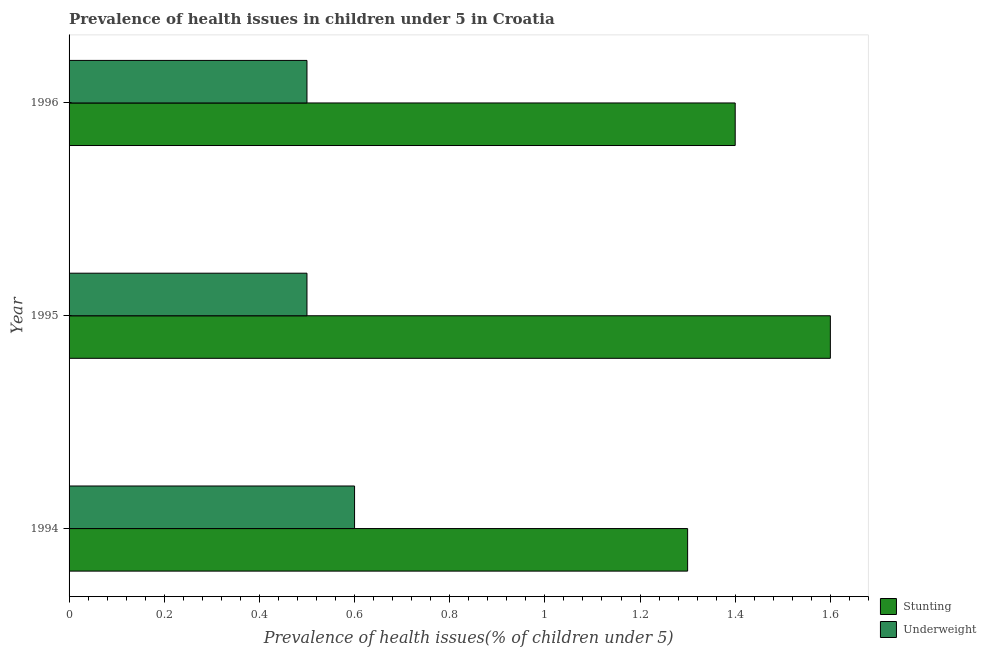Are the number of bars per tick equal to the number of legend labels?
Keep it short and to the point. Yes. Are the number of bars on each tick of the Y-axis equal?
Give a very brief answer. Yes. How many bars are there on the 2nd tick from the top?
Make the answer very short. 2. How many bars are there on the 2nd tick from the bottom?
Provide a short and direct response. 2. In how many cases, is the number of bars for a given year not equal to the number of legend labels?
Your response must be concise. 0. What is the percentage of stunted children in 1994?
Give a very brief answer. 1.3. Across all years, what is the maximum percentage of underweight children?
Your answer should be compact. 0.6. Across all years, what is the minimum percentage of underweight children?
Ensure brevity in your answer.  0.5. In which year was the percentage of underweight children maximum?
Your answer should be compact. 1994. In which year was the percentage of underweight children minimum?
Provide a succinct answer. 1995. What is the total percentage of stunted children in the graph?
Offer a very short reply. 4.3. What is the difference between the percentage of stunted children in 1995 and the percentage of underweight children in 1996?
Your answer should be very brief. 1.1. What is the average percentage of stunted children per year?
Your answer should be very brief. 1.43. Is the percentage of underweight children in 1994 less than that in 1995?
Your response must be concise. No. Is the difference between the percentage of underweight children in 1994 and 1995 greater than the difference between the percentage of stunted children in 1994 and 1995?
Make the answer very short. Yes. What is the difference between the highest and the second highest percentage of underweight children?
Provide a succinct answer. 0.1. In how many years, is the percentage of underweight children greater than the average percentage of underweight children taken over all years?
Provide a short and direct response. 1. Is the sum of the percentage of stunted children in 1994 and 1995 greater than the maximum percentage of underweight children across all years?
Your answer should be very brief. Yes. What does the 2nd bar from the top in 1994 represents?
Offer a terse response. Stunting. What does the 2nd bar from the bottom in 1995 represents?
Provide a succinct answer. Underweight. Are all the bars in the graph horizontal?
Provide a succinct answer. Yes. How many years are there in the graph?
Your response must be concise. 3. Are the values on the major ticks of X-axis written in scientific E-notation?
Offer a very short reply. No. Does the graph contain any zero values?
Offer a terse response. No. Where does the legend appear in the graph?
Make the answer very short. Bottom right. How are the legend labels stacked?
Your answer should be very brief. Vertical. What is the title of the graph?
Keep it short and to the point. Prevalence of health issues in children under 5 in Croatia. Does "Resident workers" appear as one of the legend labels in the graph?
Give a very brief answer. No. What is the label or title of the X-axis?
Give a very brief answer. Prevalence of health issues(% of children under 5). What is the label or title of the Y-axis?
Provide a succinct answer. Year. What is the Prevalence of health issues(% of children under 5) in Stunting in 1994?
Make the answer very short. 1.3. What is the Prevalence of health issues(% of children under 5) in Underweight in 1994?
Keep it short and to the point. 0.6. What is the Prevalence of health issues(% of children under 5) in Stunting in 1995?
Your response must be concise. 1.6. What is the Prevalence of health issues(% of children under 5) of Stunting in 1996?
Your answer should be compact. 1.4. Across all years, what is the maximum Prevalence of health issues(% of children under 5) of Stunting?
Make the answer very short. 1.6. Across all years, what is the maximum Prevalence of health issues(% of children under 5) in Underweight?
Offer a terse response. 0.6. Across all years, what is the minimum Prevalence of health issues(% of children under 5) in Stunting?
Your answer should be compact. 1.3. Across all years, what is the minimum Prevalence of health issues(% of children under 5) in Underweight?
Keep it short and to the point. 0.5. What is the total Prevalence of health issues(% of children under 5) of Underweight in the graph?
Your answer should be compact. 1.6. What is the difference between the Prevalence of health issues(% of children under 5) in Stunting in 1994 and that in 1995?
Keep it short and to the point. -0.3. What is the difference between the Prevalence of health issues(% of children under 5) of Underweight in 1994 and that in 1995?
Ensure brevity in your answer.  0.1. What is the difference between the Prevalence of health issues(% of children under 5) of Stunting in 1994 and that in 1996?
Provide a short and direct response. -0.1. What is the difference between the Prevalence of health issues(% of children under 5) in Underweight in 1994 and that in 1996?
Your response must be concise. 0.1. What is the difference between the Prevalence of health issues(% of children under 5) of Underweight in 1995 and that in 1996?
Your answer should be very brief. 0. What is the average Prevalence of health issues(% of children under 5) of Stunting per year?
Give a very brief answer. 1.43. What is the average Prevalence of health issues(% of children under 5) of Underweight per year?
Give a very brief answer. 0.53. In the year 1994, what is the difference between the Prevalence of health issues(% of children under 5) of Stunting and Prevalence of health issues(% of children under 5) of Underweight?
Provide a short and direct response. 0.7. In the year 1996, what is the difference between the Prevalence of health issues(% of children under 5) of Stunting and Prevalence of health issues(% of children under 5) of Underweight?
Ensure brevity in your answer.  0.9. What is the ratio of the Prevalence of health issues(% of children under 5) in Stunting in 1994 to that in 1995?
Give a very brief answer. 0.81. What is the ratio of the Prevalence of health issues(% of children under 5) of Underweight in 1994 to that in 1995?
Provide a succinct answer. 1.2. What is the ratio of the Prevalence of health issues(% of children under 5) in Underweight in 1994 to that in 1996?
Provide a short and direct response. 1.2. What is the ratio of the Prevalence of health issues(% of children under 5) in Underweight in 1995 to that in 1996?
Provide a succinct answer. 1. 